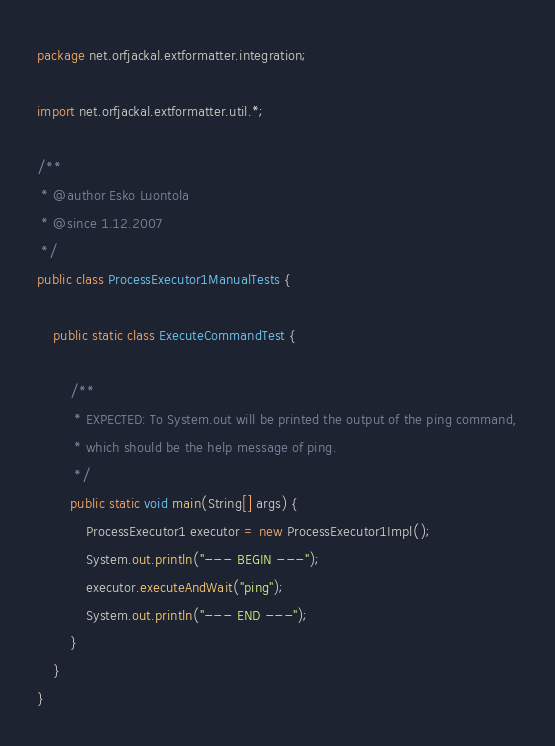<code> <loc_0><loc_0><loc_500><loc_500><_Java_>package net.orfjackal.extformatter.integration;

import net.orfjackal.extformatter.util.*;

/**
 * @author Esko Luontola
 * @since 1.12.2007
 */
public class ProcessExecutor1ManualTests {

    public static class ExecuteCommandTest {

        /**
         * EXPECTED: To System.out will be printed the output of the ping command,
         * which should be the help message of ping.
         */
        public static void main(String[] args) {
            ProcessExecutor1 executor = new ProcessExecutor1Impl();
            System.out.println("--- BEGIN ---");
            executor.executeAndWait("ping");
            System.out.println("--- END ---");
        }
    }
}
</code> 